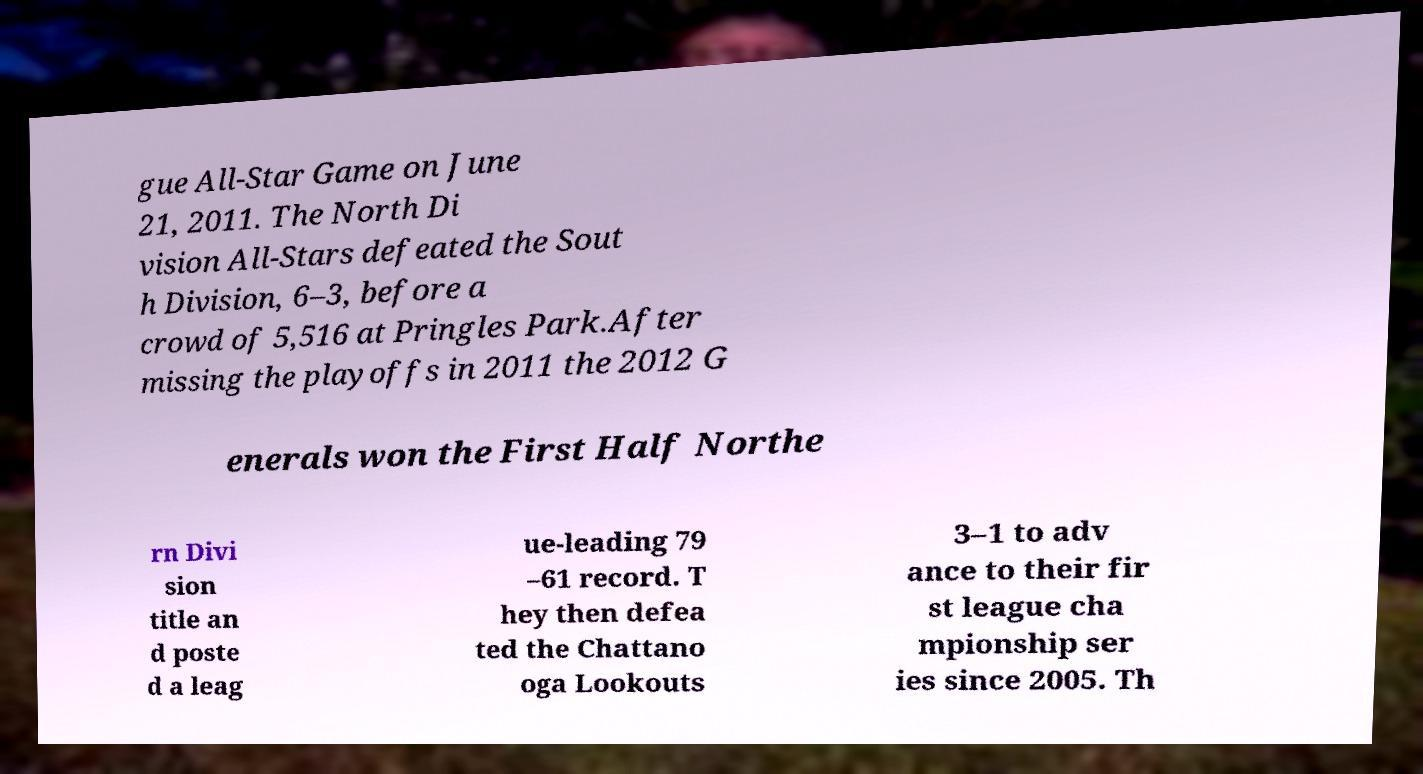Could you assist in decoding the text presented in this image and type it out clearly? gue All-Star Game on June 21, 2011. The North Di vision All-Stars defeated the Sout h Division, 6–3, before a crowd of 5,516 at Pringles Park.After missing the playoffs in 2011 the 2012 G enerals won the First Half Northe rn Divi sion title an d poste d a leag ue-leading 79 –61 record. T hey then defea ted the Chattano oga Lookouts 3–1 to adv ance to their fir st league cha mpionship ser ies since 2005. Th 